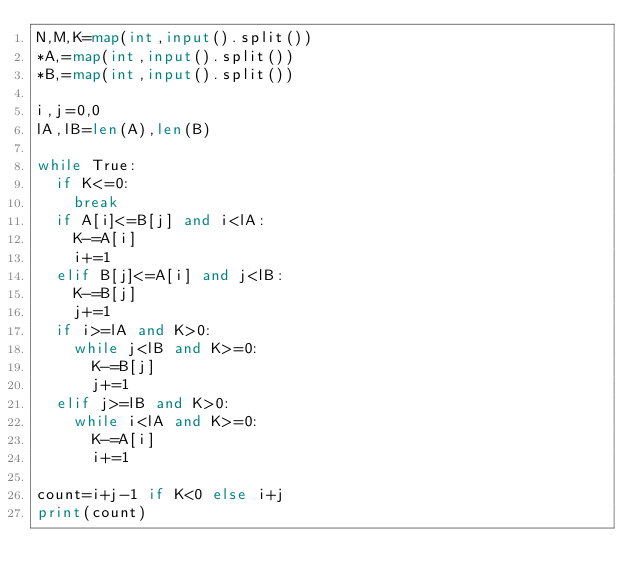<code> <loc_0><loc_0><loc_500><loc_500><_Python_>N,M,K=map(int,input().split())
*A,=map(int,input().split())
*B,=map(int,input().split())

i,j=0,0
lA,lB=len(A),len(B)

while True:
  if K<=0:
    break
  if A[i]<=B[j] and i<lA:
    K-=A[i]  
    i+=1  
  elif B[j]<=A[i] and j<lB:
    K-=B[j]     
    j+=1
  if i>=lA and K>0:
    while j<lB and K>=0:
      K-=B[j]
      j+=1
  elif j>=lB and K>0:
    while i<lA and K>=0:
      K-=A[i]
      i+=1

count=i+j-1 if K<0 else i+j
print(count)</code> 